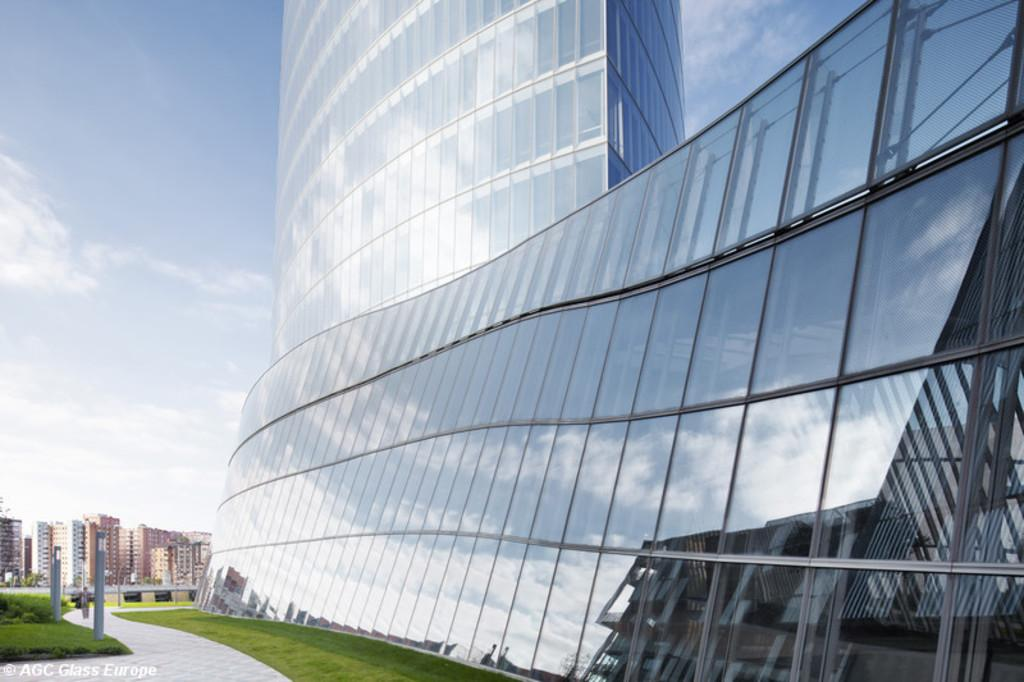What type of building is in the image? There is a glass building in the image. What can be seen in the background of the image? In the background, there are poles, green grass, and other buildings. What is the color of the sky in the image? The sky is visible in the image, with a combination of white and blue colors. How much salt is present in the image? There is no salt present in the image. What type of debt is being discussed in the image? There is no discussion of debt in the image. 